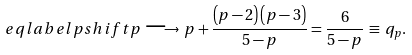<formula> <loc_0><loc_0><loc_500><loc_500>\ e q l a b e l { p s h i f t } p \, \longrightarrow \, p + \frac { \left ( p - 2 \right ) \left ( p - 3 \right ) } { 5 - p } = \frac { 6 } { 5 - p } \, \equiv \, q _ { p } .</formula> 